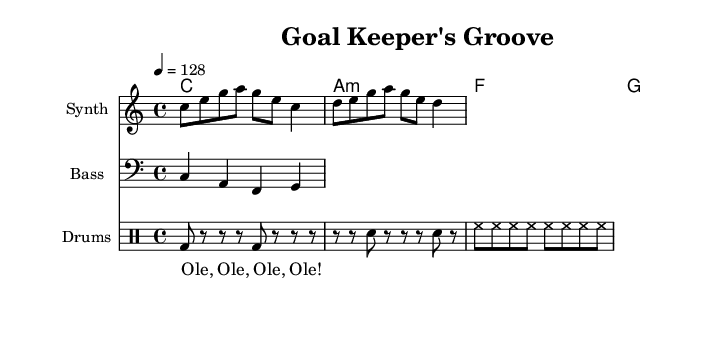What is the key signature of this music? The key signature is C major, which has no sharps or flats.
Answer: C major What is the time signature of this piece? The time signature is indicated by the "4/4" signature, meaning there are four beats in each measure.
Answer: 4/4 What is the tempo marking of the music? The tempo marking is shown as "4 = 128", indicating the metronome beats per minute for this piece.
Answer: 128 How many total measures are in the melody section? By counting the rhythmic values in the melody, a total of eight measures can be identified for the excerpt given.
Answer: 8 What kind of rhythm does the drum pattern primarily use? The drum pattern mainly employs a combination of bass drums, snare drums, and hi-hats, typical for electronic dance music, providing a driving beat.
Answer: Driving beat What is the function of the soccer chant in this music? The soccer chant serves as a lyrical element that enhances the upbeat energy typical of dance music, creating an engaging atmosphere for listeners.
Answer: Engaging atmosphere What type of chords are used in the harmony section? The chords consist of a major chord (C), a minor chord (A minor), and two more major chords (F and G), indicating a mix used frequently in dance music for an uplifting feel.
Answer: Major and minor chords 